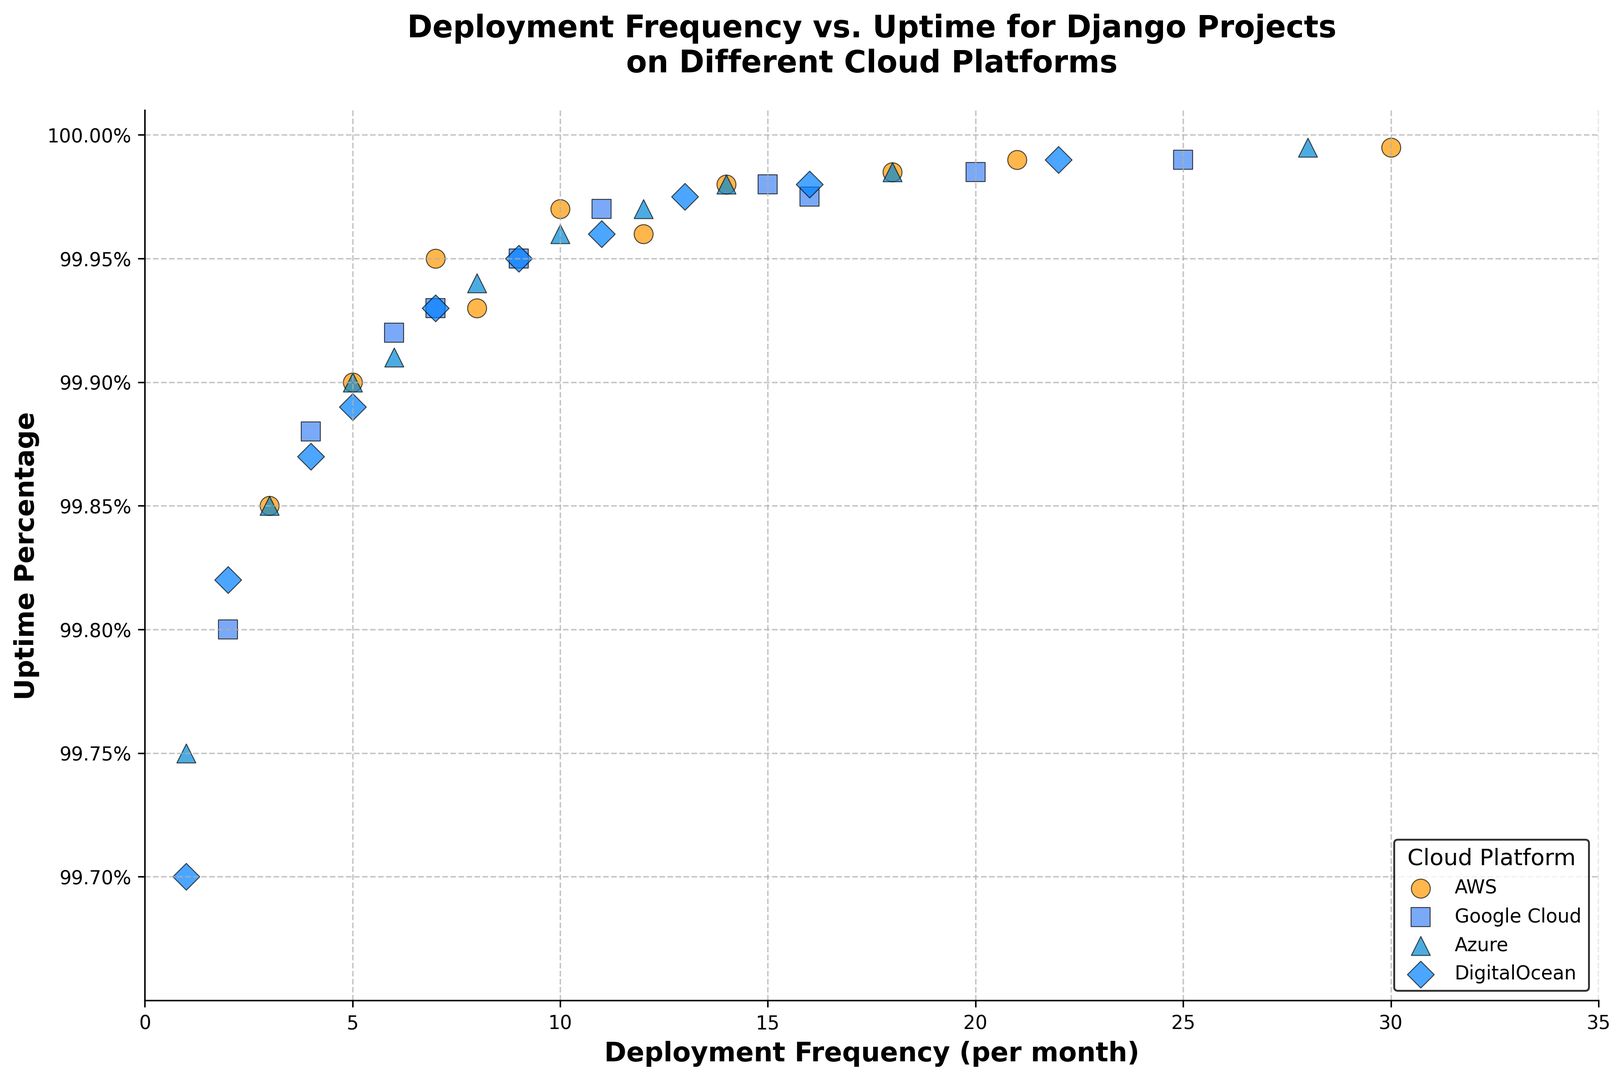What is the highest uptime percentage for AWS? The figure shows several points representing the uptime percentage for AWS. The exact values for AWS can be spotted by looking at the ‘o’ markers with a color code that is orange. Among these, the highest point is at 99.995.
Answer: 99.995% Which cloud platform has the lowest deployment frequency and what is it? The figure depicts different marker shapes for each cloud platform. The lowest deployment frequency is indicated by the smallest x-value on the respective markers. The figure shows a diamond marker at the x-value 1 for DigitalOcean.
Answer: DigitalOcean, 1 Compare the deployment frequencies of Google Cloud when the uptime percentage is 99.98%. To answer this, locate the ‘s’ markers (representing Google Cloud) at the y-value of 99.98. There are two such markers, one around x = 15 and one close to x = 16.
Answer: 15 and 16 Which cloud platform has more points (hence more data points collected)? Count the number of markers for each cloud platform. AWS (orange circles) has 10 points, Google Cloud (blue squares) has 10 points, Azure (blue triangles) has 10 points, and DigitalOcean (blue diamonds) has 10 points. All have the same number of data points.
Answer: All have 10 points What is the difference between the highest deployment frequency for AWS and the lowest deployment frequency for Google Cloud? Identify the highest deployment frequency for AWS, which is 30, and the lowest for Google Cloud, which is 2. The difference is 30 - 2 = 28.
Answer: 28 What is the average uptime percentage for Azure when deployment frequency is 10 or above? According to the figure, Azure markers (triangles) at x-values 10, 12, 14, 18, and 28 all have uptime percentages of 99.96, 99.97, 99.98, 99.985, and 99.995 respectively. The average is (99.96 + 99.97 + 99.98 + 99.985 + 99.995) / 5 = 99.978.
Answer: 99.978 Which cloud platform has its highest uptime percentage furthest to the right on the plot? The plot shows deployment frequency on the x-axis and uptime percentage on the y-axis. By locating the rightmost points with the highest y-values for each platform, Azure has its highest uptime percentage point at x = 28.
Answer: Azure Compare the markers representing AWS and DigitalOcean at an uptime percentage of 99.96%. What are their deployment frequencies? Identify the markers for AWS (circles) and DigitalOcean (diamonds) at the y-value of 99.96. AWS has one marker around x = 12 and DigitalOcean has one around x = 11.
Answer: AWS: 12, DigitalOcean: 11 Which platform shows the widest range in deployment frequency? Examine the range of deployment frequencies within each platform by subtracting the smallest x-value from the largest. AWS ranges from 3 to 30 (27), Google Cloud from 2 to 25 (23), Azure from 1 to 28 (27), and DigitalOcean from 1 to 22 (21). AWS and Azure both have the widest range of 27.
Answer: AWS and Azure What is the median deployment frequency for Google Cloud? For Google Cloud ('s' markers), the deployment frequencies are: 2, 4, 6, 7, 9, 11, 15, 16, 20, 25. The median, or middle value, is the average of the 5th and 6th values when sorted: (9+11)/2=10.
Answer: 10 